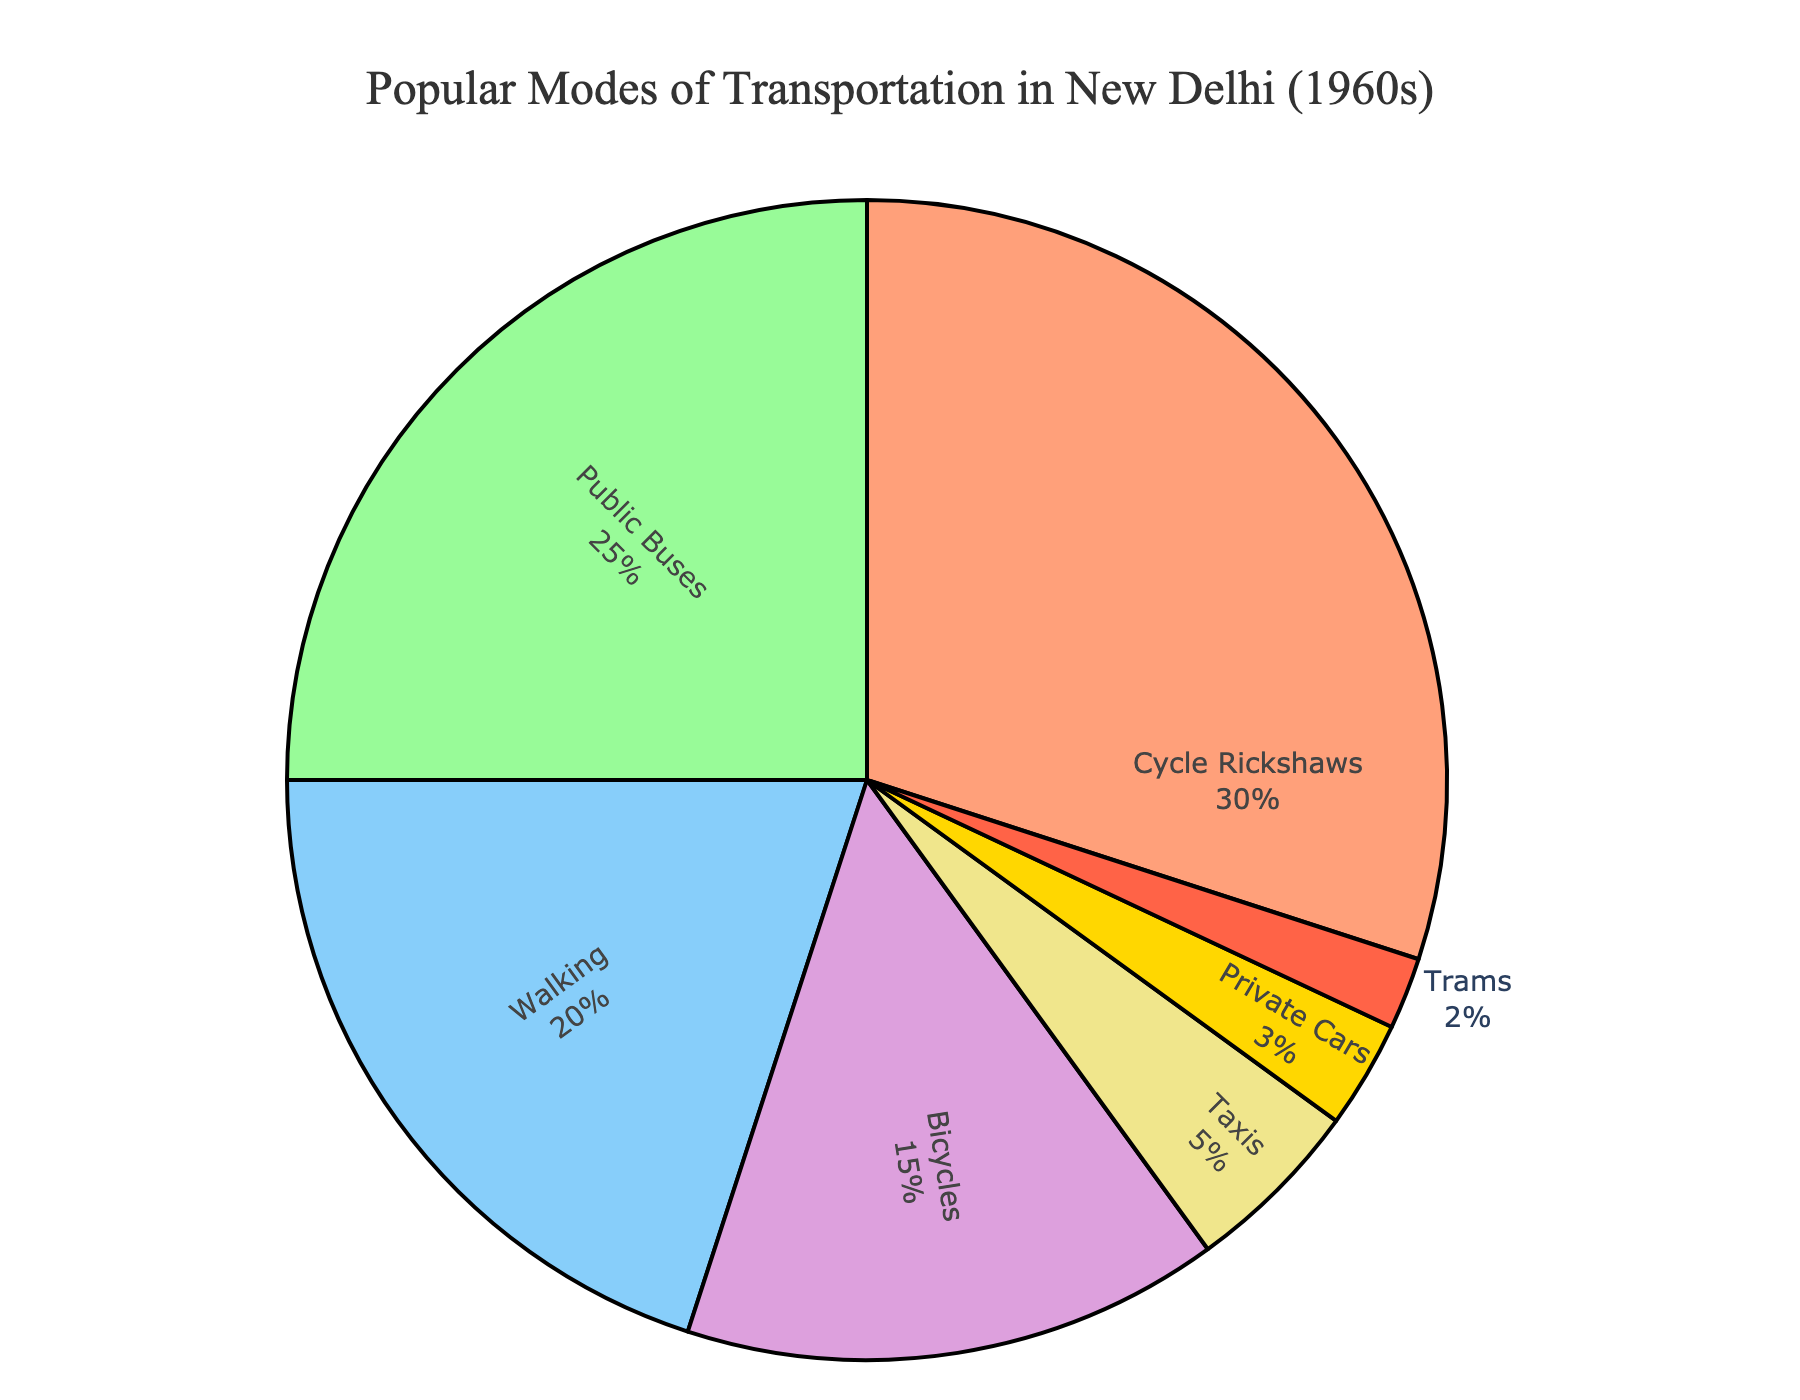What percentage of transportation modes did non-motorized options (Cycle Rickshaws, Walking, and Bicycles) account for? First, identify the percentages for Cycle Rickshaws (30%), Walking (20%), and Bicycles (15%). Then, sum these values: 30% + 20% + 15% = 65%
Answer: 65% Which mode of transportation was less popular: Private Cars or Trams? Compare the percentages for Private Cars (3%) and Trams (2%). Trams have a lower percentage.
Answer: Trams What's the difference in percentage between the most popular and the least popular modes of transportation? The most popular mode is Cycle Rickshaws (30%), and the least popular is Trams (2%). The difference is 30% - 2% = 28%.
Answer: 28% How much more popular were Public Buses compared to Taxis? Public Buses accounted for 25%, and Taxis for 5%. The difference is 25% - 5% = 20%.
Answer: 20% List the modes of transportation that together account for more than half (50%) of the transportation mix. Identify the modes and their percentages: Cycle Rickshaws (30%), Public Buses (25%), and Walking (20%). Adding these, 30% + 25% = 55%, which is already more than 50%. So Cycle Rickshaws and Public Buses alone account for more than half.
Answer: Cycle Rickshaws and Public Buses Which visual elements highlight the nostalgic nature of the chart? The title and the annotation provide a nostalgic touch. The title "Popular Modes of Transportation in New Delhi (1960s)" and the annotation "Ah, the good old days..." are the elements that highlight nostalgia.
Answer: Title and annotation Among Cycle Rickshaws, Bicycles, and Walking, which was the second most popular mode of transportation? Compare the percentages for Cycle Rickshaws (30%), Bicycles (15%), and Walking (20%). Walking is the second most popular.
Answer: Walking If you combined the percentages of Taxis and Private Cars, could they surpass Bicycles? Add the percentages for Taxis (5%) and Private Cars (3%), 5% + 3% = 8%. This is less than the percentage for Bicycles (15%).
Answer: No 